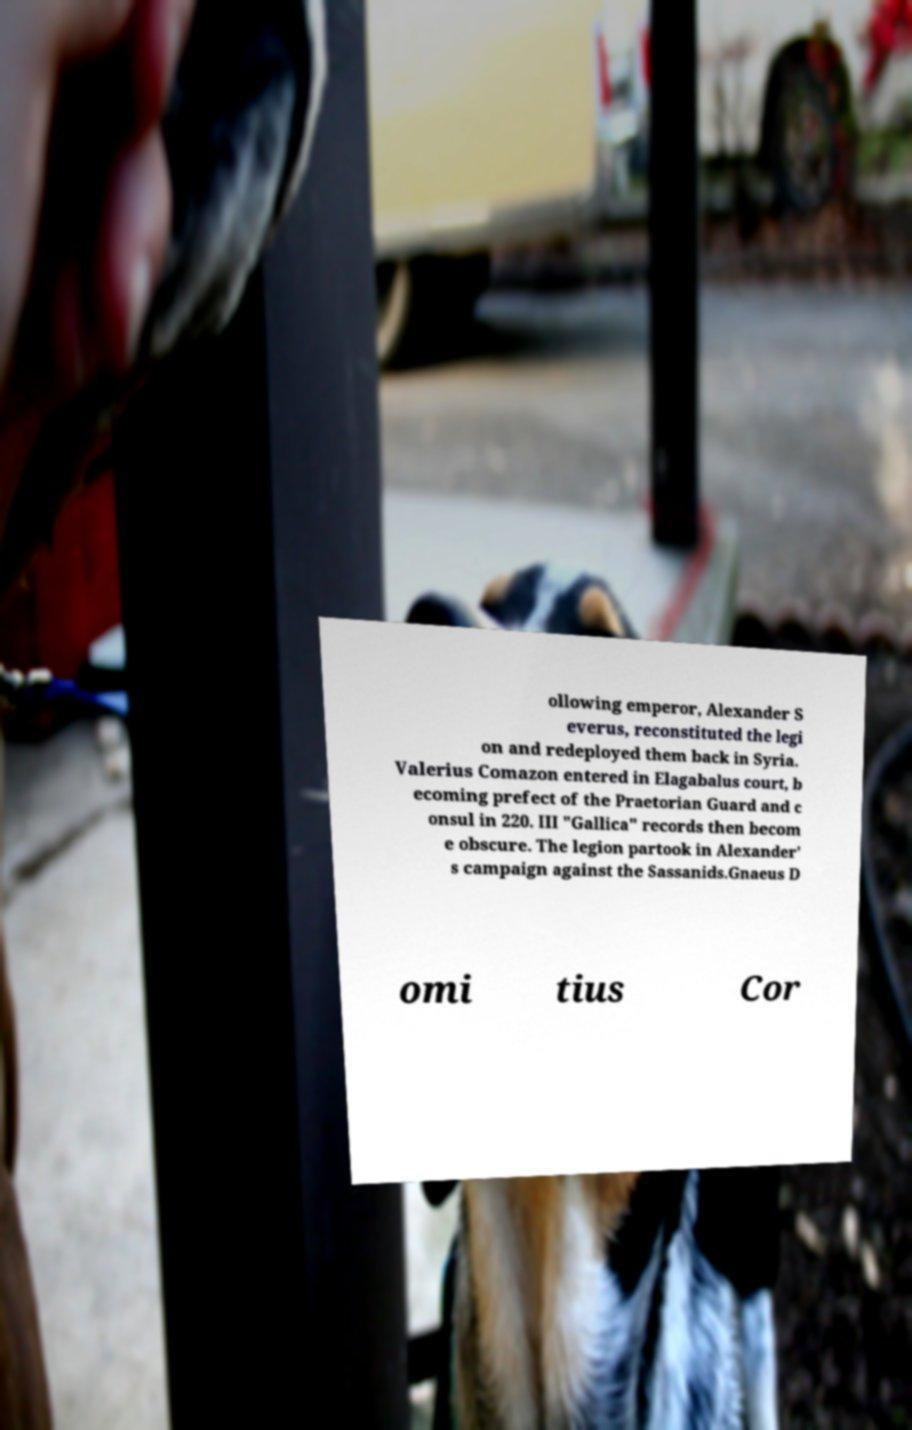I need the written content from this picture converted into text. Can you do that? ollowing emperor, Alexander S everus, reconstituted the legi on and redeployed them back in Syria. Valerius Comazon entered in Elagabalus court, b ecoming prefect of the Praetorian Guard and c onsul in 220. III "Gallica" records then becom e obscure. The legion partook in Alexander' s campaign against the Sassanids.Gnaeus D omi tius Cor 